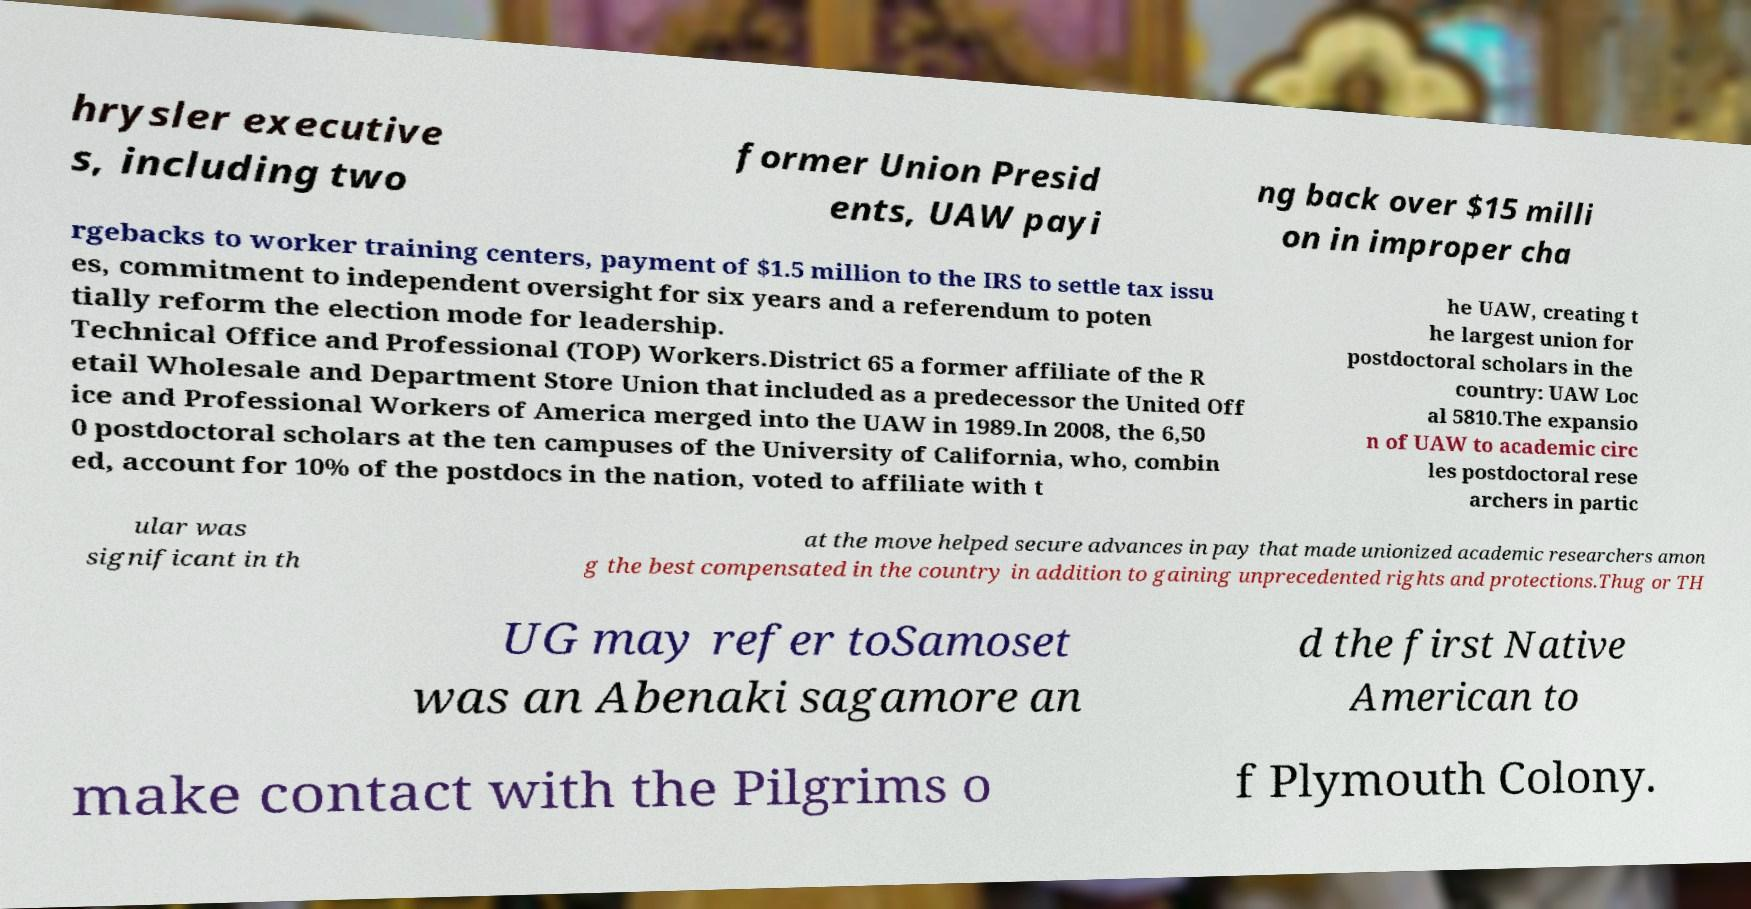Could you assist in decoding the text presented in this image and type it out clearly? hrysler executive s, including two former Union Presid ents, UAW payi ng back over $15 milli on in improper cha rgebacks to worker training centers, payment of $1.5 million to the IRS to settle tax issu es, commitment to independent oversight for six years and a referendum to poten tially reform the election mode for leadership. Technical Office and Professional (TOP) Workers.District 65 a former affiliate of the R etail Wholesale and Department Store Union that included as a predecessor the United Off ice and Professional Workers of America merged into the UAW in 1989.In 2008, the 6,50 0 postdoctoral scholars at the ten campuses of the University of California, who, combin ed, account for 10% of the postdocs in the nation, voted to affiliate with t he UAW, creating t he largest union for postdoctoral scholars in the country: UAW Loc al 5810.The expansio n of UAW to academic circ les postdoctoral rese archers in partic ular was significant in th at the move helped secure advances in pay that made unionized academic researchers amon g the best compensated in the country in addition to gaining unprecedented rights and protections.Thug or TH UG may refer toSamoset was an Abenaki sagamore an d the first Native American to make contact with the Pilgrims o f Plymouth Colony. 